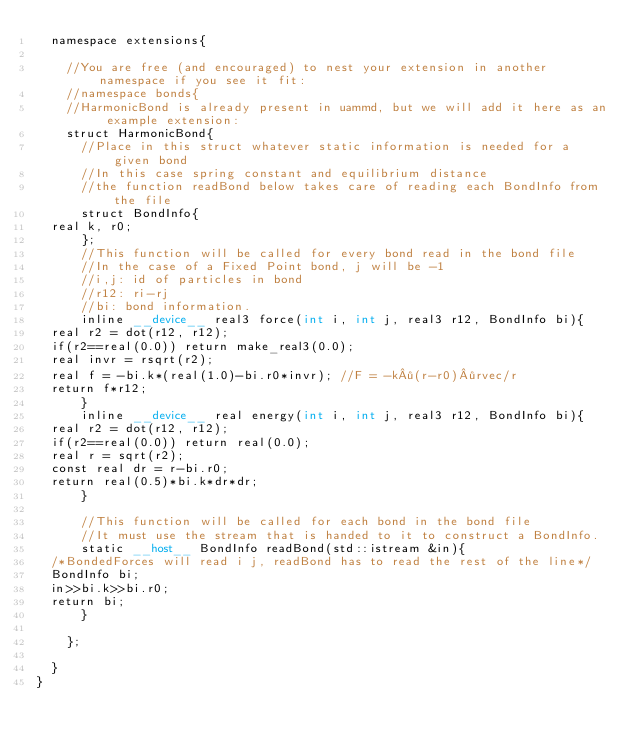Convert code to text. <code><loc_0><loc_0><loc_500><loc_500><_Cuda_>  namespace extensions{

    //You are free (and encouraged) to nest your extension in another namespace if you see it fit:
    //namespace bonds{
    //HarmonicBond is already present in uammd, but we will add it here as an example extension:
    struct HarmonicBond{
      //Place in this struct whatever static information is needed for a given bond
      //In this case spring constant and equilibrium distance
      //the function readBond below takes care of reading each BondInfo from the file
      struct BondInfo{
	real k, r0;
      };
      //This function will be called for every bond read in the bond file
      //In the case of a Fixed Point bond, j will be -1
      //i,j: id of particles in bond
      //r12: ri-rj
      //bi: bond information.
      inline __device__ real3 force(int i, int j, real3 r12, BondInfo bi){
	real r2 = dot(r12, r12);
	if(r2==real(0.0)) return make_real3(0.0);
	real invr = rsqrt(r2);
	real f = -bi.k*(real(1.0)-bi.r0*invr); //F = -k·(r-r0)·rvec/r
	return f*r12;
      }
      inline __device__ real energy(int i, int j, real3 r12, BondInfo bi){
	real r2 = dot(r12, r12);
	if(r2==real(0.0)) return real(0.0);
	real r = sqrt(r2);
	const real dr = r-bi.r0;
	return real(0.5)*bi.k*dr*dr;
      }

      //This function will be called for each bond in the bond file
      //It must use the stream that is handed to it to construct a BondInfo.  
      static __host__ BondInfo readBond(std::istream &in){
	/*BondedForces will read i j, readBond has to read the rest of the line*/
	BondInfo bi;
	in>>bi.k>>bi.r0;
	return bi;
      }

    };

  }
}
</code> 